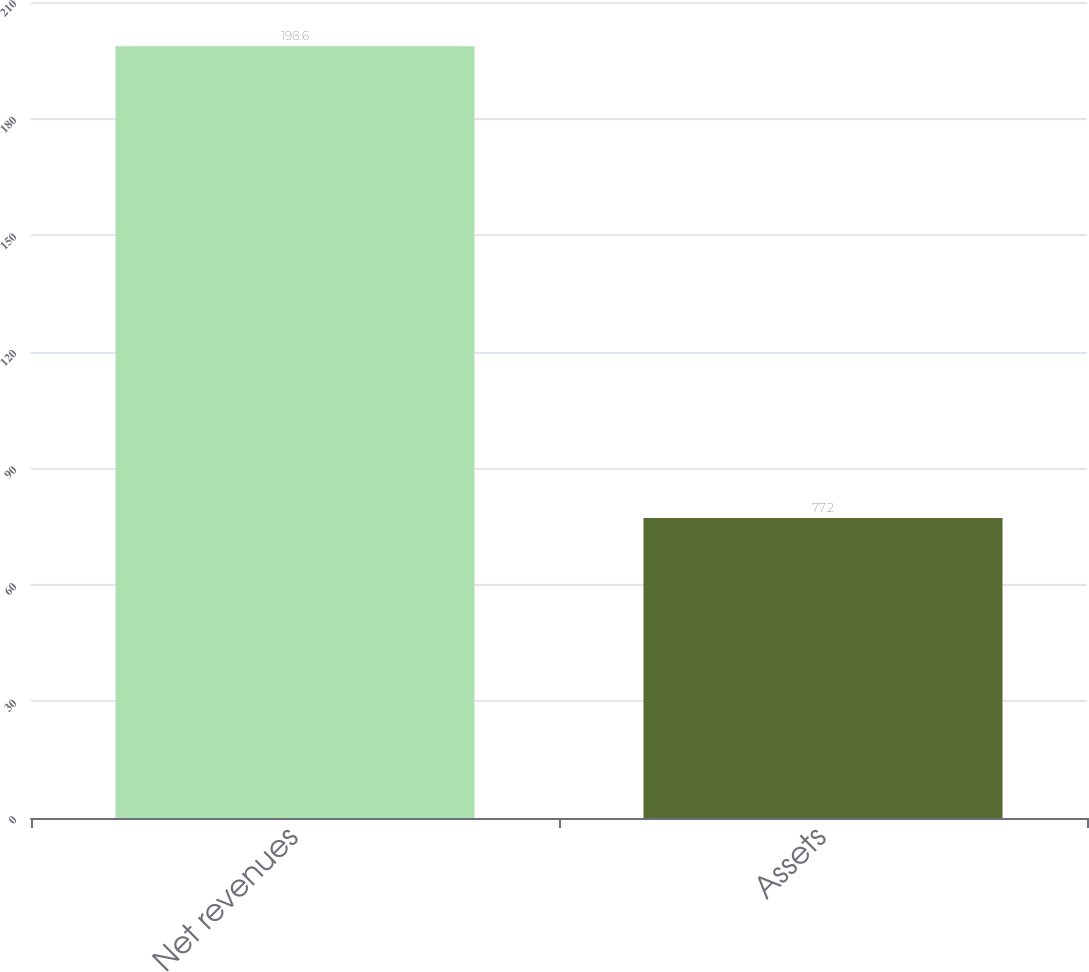Convert chart to OTSL. <chart><loc_0><loc_0><loc_500><loc_500><bar_chart><fcel>Net revenues<fcel>Assets<nl><fcel>198.6<fcel>77.2<nl></chart> 